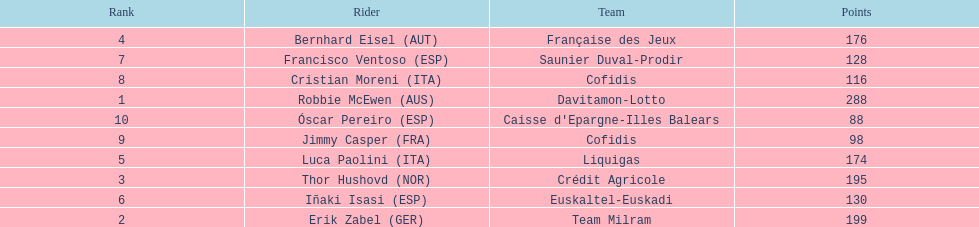How many points did robbie mcewen and cristian moreni score together? 404. 